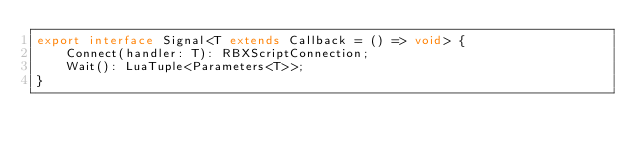Convert code to text. <code><loc_0><loc_0><loc_500><loc_500><_TypeScript_>export interface Signal<T extends Callback = () => void> {
	Connect(handler: T): RBXScriptConnection;
	Wait(): LuaTuple<Parameters<T>>;
}
</code> 